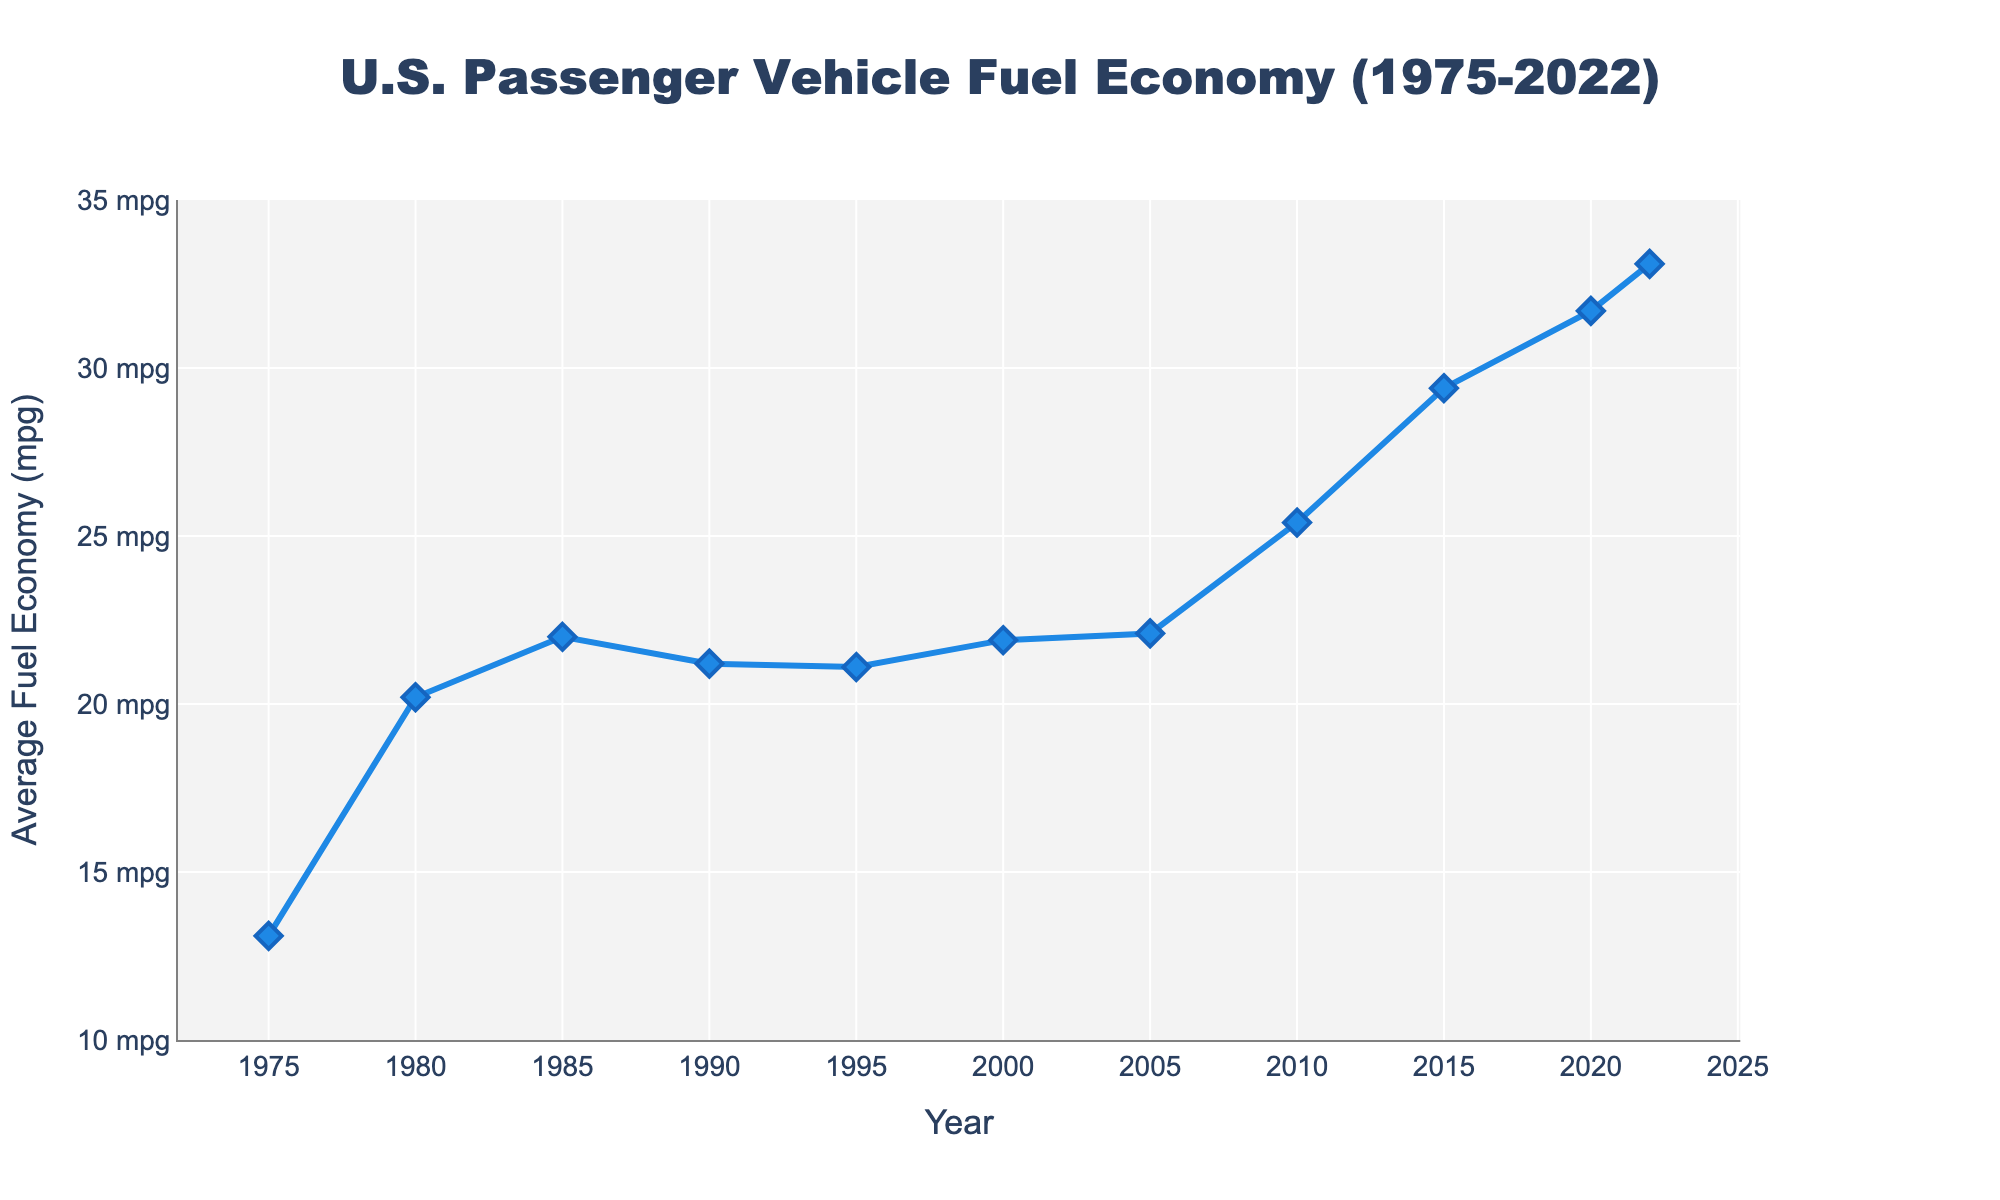What was the average fuel economy in 1975? According to the figure, the fuel economy for 1975 is indicated by the data point at the bottom left of the chart. The hovertext shows "Fuel Economy: 13.1 mpg."
Answer: 13.1 mpg Which year did the average fuel economy first exceed 30 mpg? Examine the trend line: the data point that first crosses the 30 mpg threshold is in the year 2020, indicated by the hovertext "Fuel Economy: 31.7 mpg."
Answer: 2020 What is the difference in average fuel economy between 1980 and 2020? Identify the fuel economy values for 1980 and 2020 from the chart – 20.2 mpg and 31.7 mpg, respectively. Subtract the 1980 value from the 2020 value: 31.7 - 20.2 = 11.5 mpg.
Answer: 11.5 mpg What is the highest recorded average fuel economy in the dataset? Scan the entire plot; the highest point is in 2022, with the hovertext showing "Fuel Economy: 33.1 mpg."
Answer: 33.1 mpg Which period saw the largest increase in average fuel economy? Compare the differences between consecutive points: the largest increase is between 2005 (22.1 mpg) and 2010 (25.4 mpg), a change of 25.4 - 22.1 = 3.3 mpg.
Answer: 2005 to 2010 During which decade did the average fuel economy decline? Notice the downward trend: between 1985 (22.0 mpg) and 1990 (21.2 mpg), the fuel economy decreased by 22.0 - 21.2 = 0.8 mpg.
Answer: 1980s How much did the average fuel economy increase from 1975 to 1980? From the figure, the fuel economy increased from 13.1 mpg in 1975 to 20.2 mpg in 1980. Calculate the increase: 20.2 - 13.1 = 7.1 mpg.
Answer: 7.1 mpg Which year had a higher average fuel economy: 1995 or 2000? Check the chart: in 1995, it was 21.1 mpg; in 2000, it was 21.9 mpg. 21.9 mpg is higher than 21.1 mpg.
Answer: 2000 Was the fuel economy in 2015 higher or lower than the overall average from 1975 to 2022? First, calculate the overall average: (13.1 + 20.2 + 22.0 + 21.2 + 21.1 + 21.9 + 22.1 + 25.4 + 29.4 + 31.7 + 33.1) / 11 ≈ 23.8 mpg. The fuel economy in 2015 is 29.4 mpg, which is higher than 23.8 mpg.
Answer: Higher 